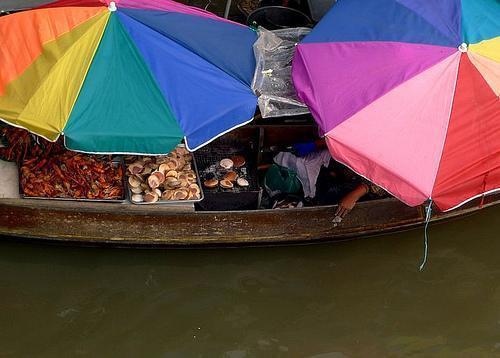How many umbrellas are shown?
Give a very brief answer. 2. How many hands are visible?
Give a very brief answer. 1. How many large umbrellas are there?
Give a very brief answer. 2. How many people in the boat?
Give a very brief answer. 1. How many umbrellas are there?
Give a very brief answer. 2. 